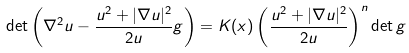<formula> <loc_0><loc_0><loc_500><loc_500>\det \left ( \nabla ^ { 2 } u - \frac { u ^ { 2 } + | \nabla u | ^ { 2 } } { 2 u } g \right ) = K ( x ) \left ( \frac { u ^ { 2 } + | \nabla u | ^ { 2 } } { 2 u } \right ) ^ { n } \det g</formula> 